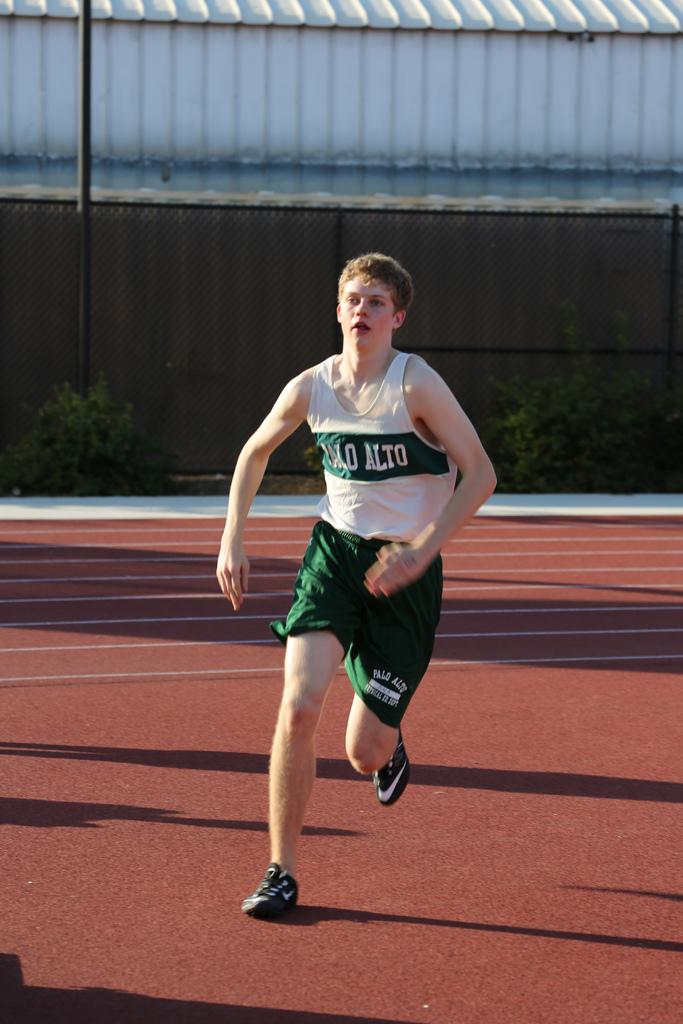What team is he running for?
Keep it short and to the point. Palo alto. 